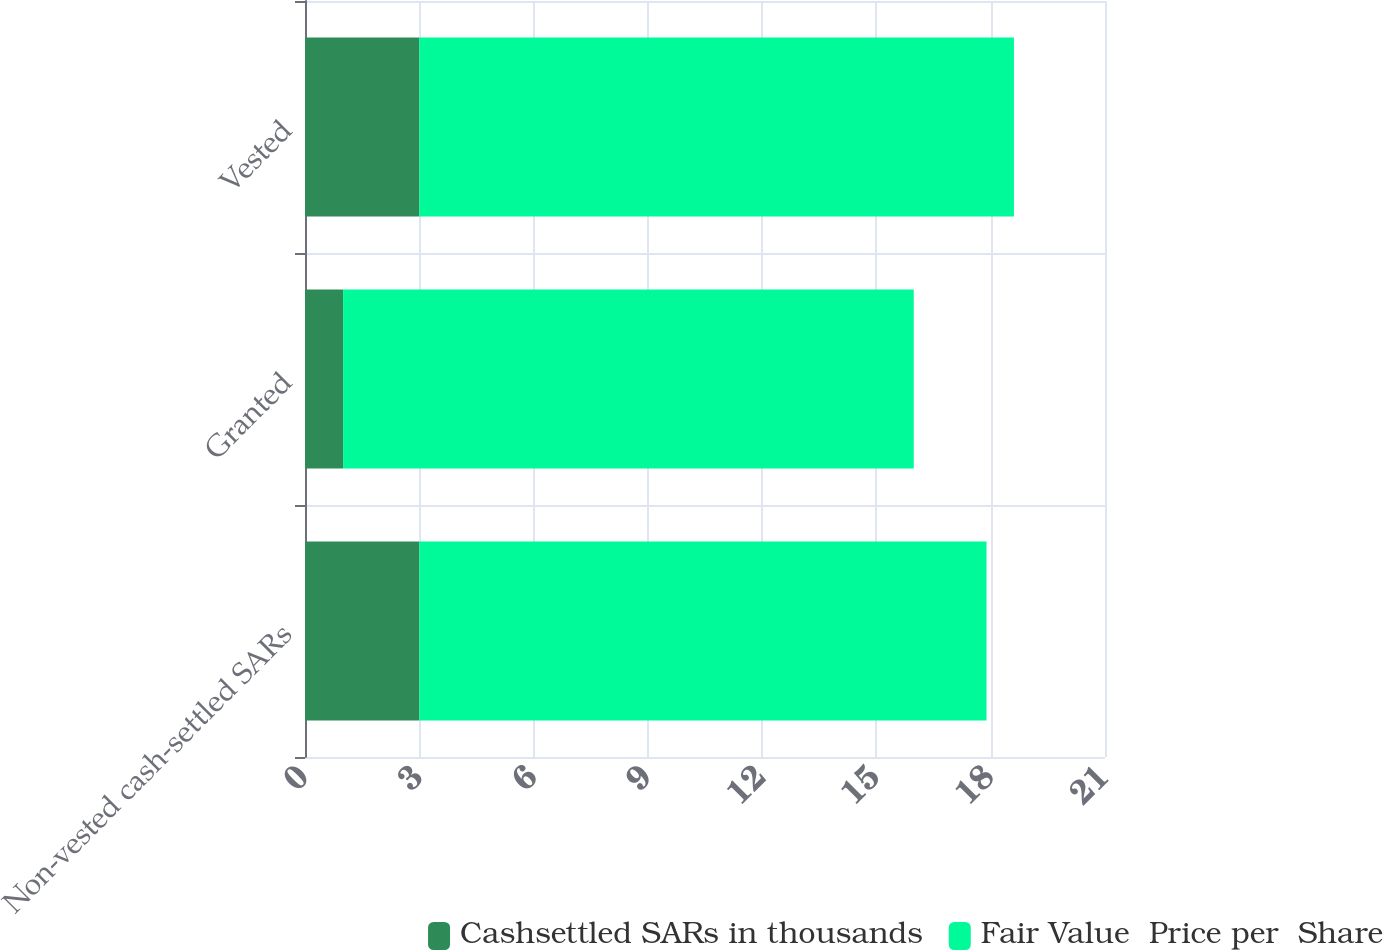Convert chart to OTSL. <chart><loc_0><loc_0><loc_500><loc_500><stacked_bar_chart><ecel><fcel>Non-vested cash-settled SARs<fcel>Granted<fcel>Vested<nl><fcel>Cashsettled SARs in thousands<fcel>3<fcel>1<fcel>3<nl><fcel>Fair Value  Price per  Share<fcel>14.89<fcel>14.98<fcel>15.61<nl></chart> 